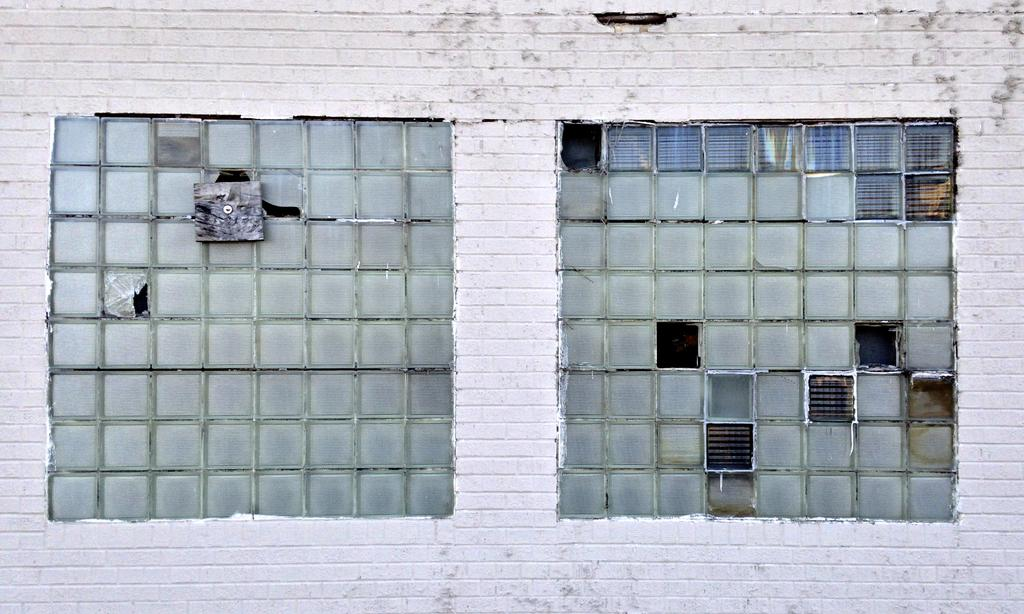What type of structure can be seen in the image? There is a wall in the image. Are there any openings in the wall? Yes, there are windows in the image. What religion is practiced in the image? There is no information about religion in the image, as it only features a wall and windows. Can you see the ocean from the windows in the image? There is no indication of the ocean or any body of water in the image, as it only features a wall and windows. 